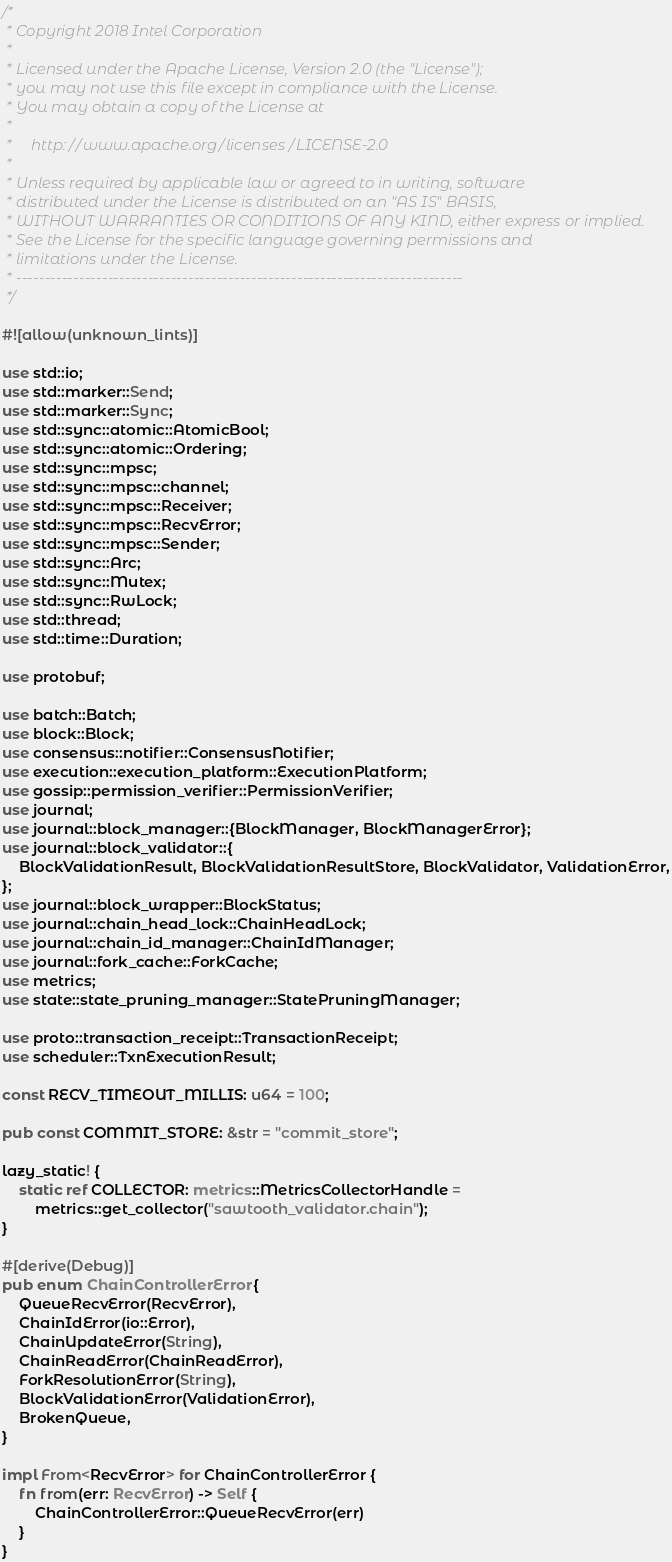Convert code to text. <code><loc_0><loc_0><loc_500><loc_500><_Rust_>/*
 * Copyright 2018 Intel Corporation
 *
 * Licensed under the Apache License, Version 2.0 (the "License");
 * you may not use this file except in compliance with the License.
 * You may obtain a copy of the License at
 *
 *     http://www.apache.org/licenses/LICENSE-2.0
 *
 * Unless required by applicable law or agreed to in writing, software
 * distributed under the License is distributed on an "AS IS" BASIS,
 * WITHOUT WARRANTIES OR CONDITIONS OF ANY KIND, either express or implied.
 * See the License for the specific language governing permissions and
 * limitations under the License.
 * ------------------------------------------------------------------------------
 */

#![allow(unknown_lints)]

use std::io;
use std::marker::Send;
use std::marker::Sync;
use std::sync::atomic::AtomicBool;
use std::sync::atomic::Ordering;
use std::sync::mpsc;
use std::sync::mpsc::channel;
use std::sync::mpsc::Receiver;
use std::sync::mpsc::RecvError;
use std::sync::mpsc::Sender;
use std::sync::Arc;
use std::sync::Mutex;
use std::sync::RwLock;
use std::thread;
use std::time::Duration;

use protobuf;

use batch::Batch;
use block::Block;
use consensus::notifier::ConsensusNotifier;
use execution::execution_platform::ExecutionPlatform;
use gossip::permission_verifier::PermissionVerifier;
use journal;
use journal::block_manager::{BlockManager, BlockManagerError};
use journal::block_validator::{
    BlockValidationResult, BlockValidationResultStore, BlockValidator, ValidationError,
};
use journal::block_wrapper::BlockStatus;
use journal::chain_head_lock::ChainHeadLock;
use journal::chain_id_manager::ChainIdManager;
use journal::fork_cache::ForkCache;
use metrics;
use state::state_pruning_manager::StatePruningManager;

use proto::transaction_receipt::TransactionReceipt;
use scheduler::TxnExecutionResult;

const RECV_TIMEOUT_MILLIS: u64 = 100;

pub const COMMIT_STORE: &str = "commit_store";

lazy_static! {
    static ref COLLECTOR: metrics::MetricsCollectorHandle =
        metrics::get_collector("sawtooth_validator.chain");
}

#[derive(Debug)]
pub enum ChainControllerError {
    QueueRecvError(RecvError),
    ChainIdError(io::Error),
    ChainUpdateError(String),
    ChainReadError(ChainReadError),
    ForkResolutionError(String),
    BlockValidationError(ValidationError),
    BrokenQueue,
}

impl From<RecvError> for ChainControllerError {
    fn from(err: RecvError) -> Self {
        ChainControllerError::QueueRecvError(err)
    }
}
</code> 